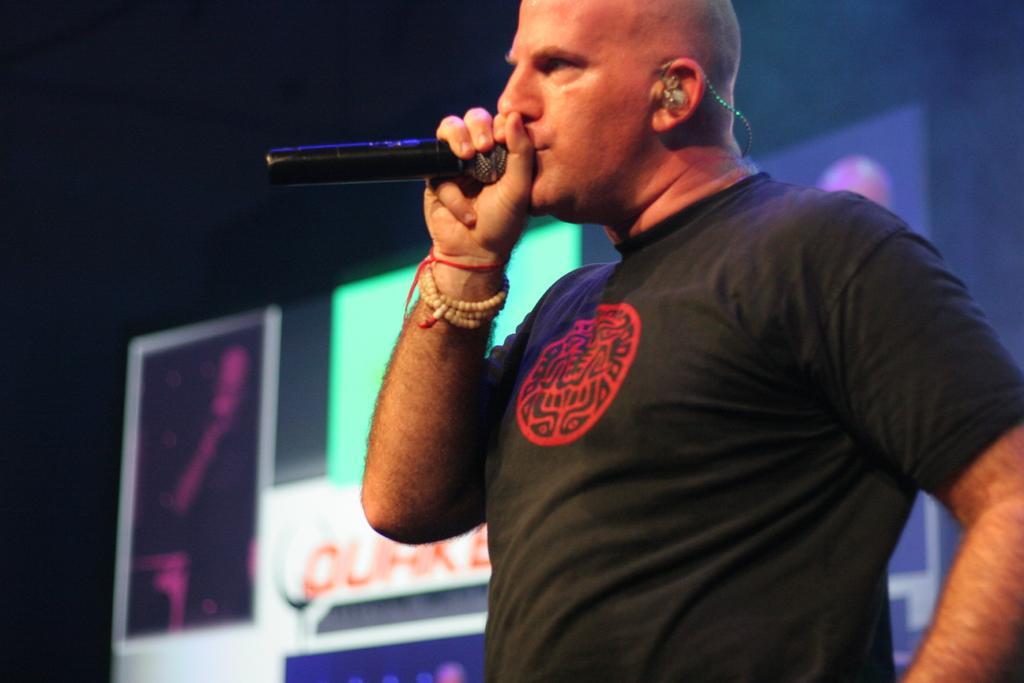Please provide a concise description of this image. A person standing in the center and is holding a mic in his hand. In the background there are some boards. 